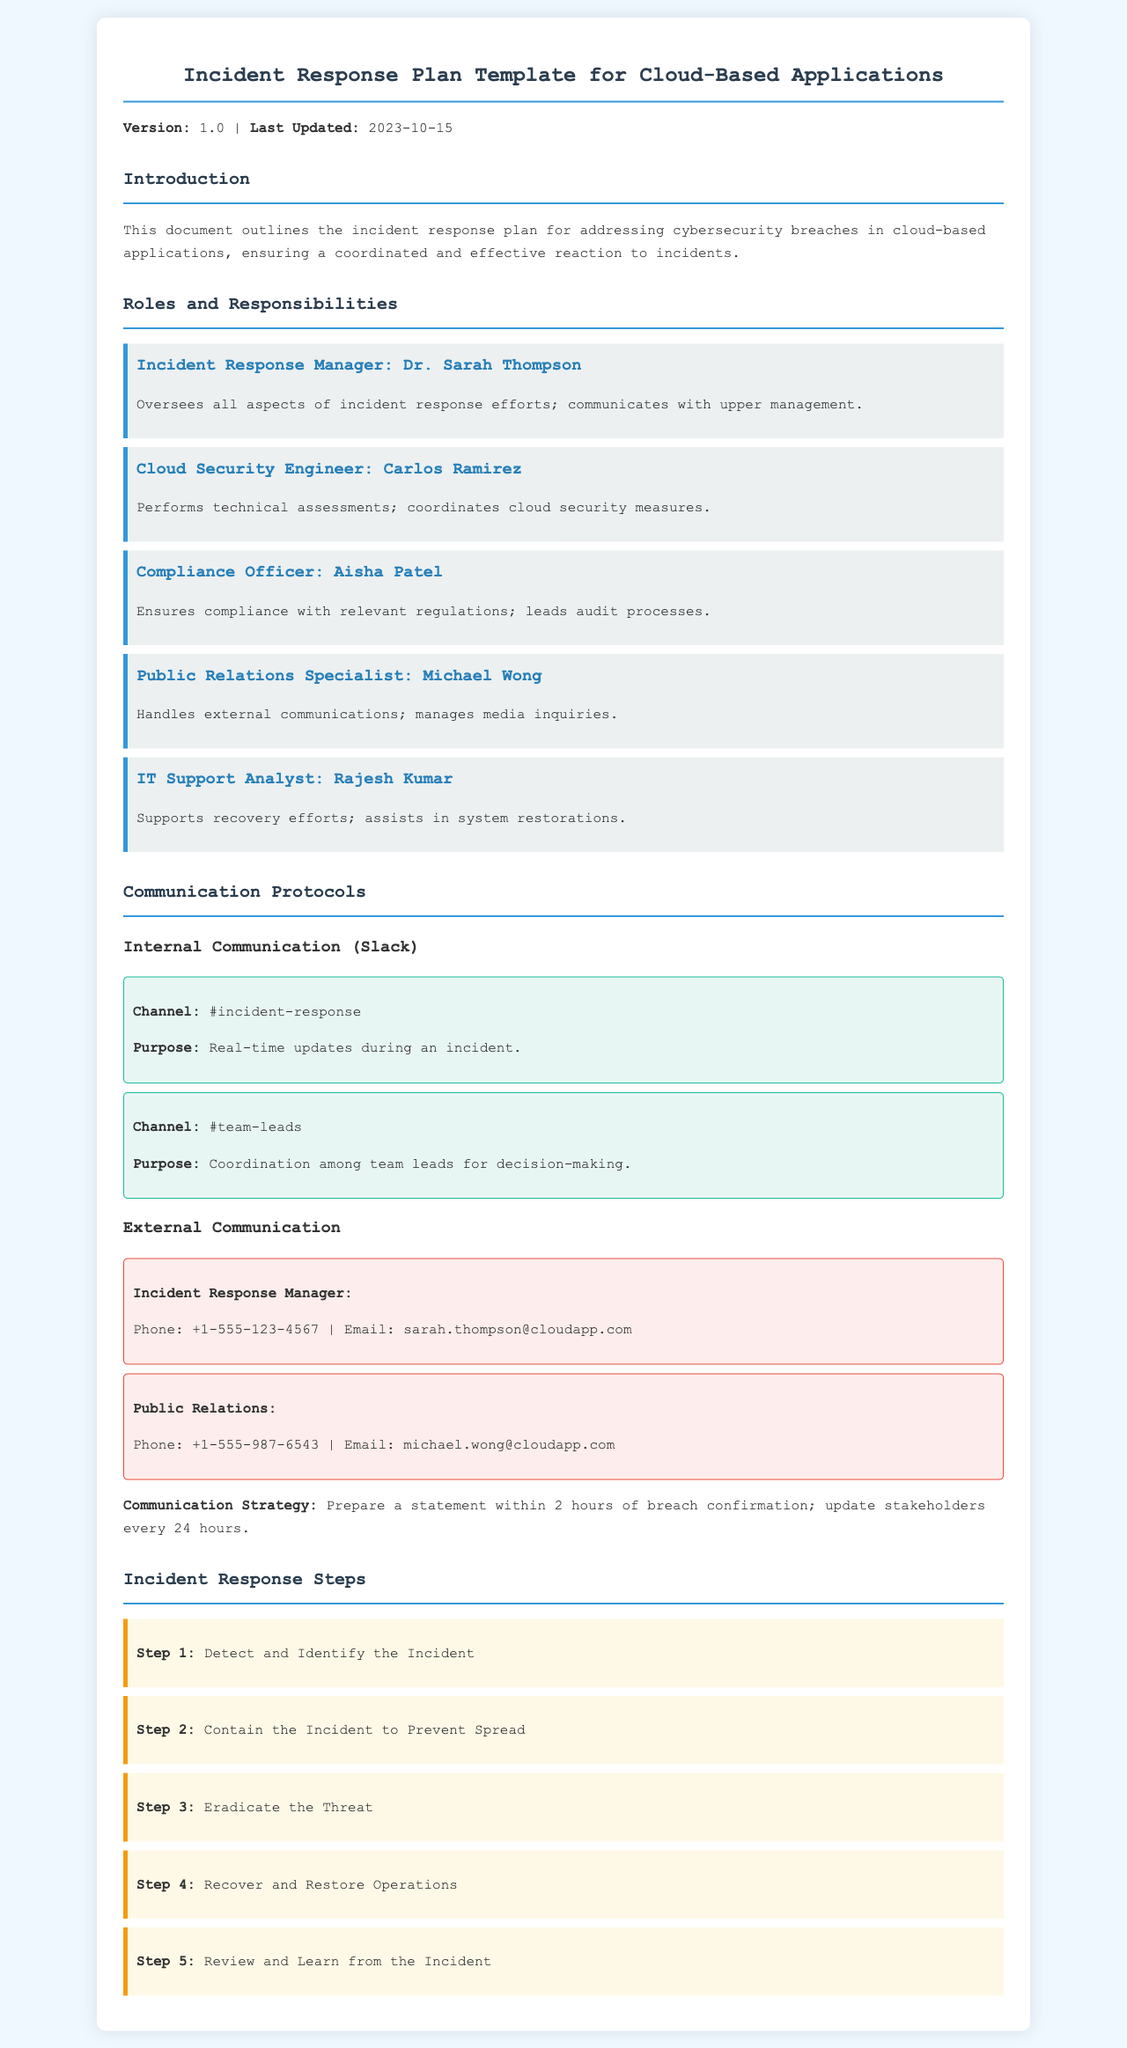What is the version of the document? The version is specified at the beginning of the document.
Answer: 1.0 Who is the Incident Response Manager? The name and title are listed under Roles and Responsibilities.
Answer: Dr. Sarah Thompson What is the purpose of the #incident-response channel? The purpose is mentioned in the communication protocols section.
Answer: Real-time updates during an incident What is the first step in the incident response? The steps are outlined in the Incident Response Steps section.
Answer: Detect and Identify the Incident What is the communication strategy for external communication? The strategy is detailed in the External Communication section.
Answer: Prepare a statement within 2 hours of breach confirmation; update stakeholders every 24 hours Who handles external communications? This information is included in the Roles and Responsibilities section.
Answer: Public Relations Specialist How many team members are listed in the Roles and Responsibilities section? The team members mentioned indicate the total count.
Answer: Five What phone number belongs to the Incident Response Manager? The phone number is provided alongside the contact information.
Answer: +1-555-123-4567 What is the email of the Public Relations Specialist? This email is given in the contact information section.
Answer: michael.wong@cloudapp.com 